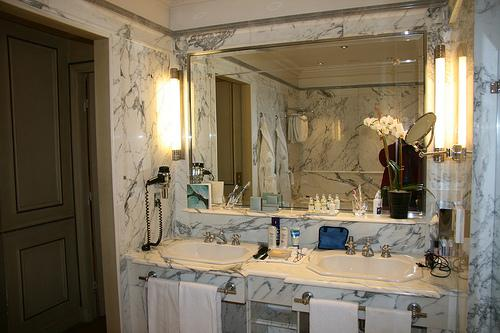What devices are mounted on the wall, and where are they located? There is a mounted light near the large mirror and a hairdryer mounted next to the right sink. Discuss the types of lights visible in the scene and their locations. There are lights on both sides of the large mirror, a light on a mirror to the left, and a light near a mirror on the right. Briefly describe the layout of the presented bathroom. It's a large bathroom with a double sink, marble counter, large mirror, lights on both sides of the mirror, wall-mounted hairdryer, and towels hanging below the counter. What items are placed on the bathroom counter? A blue bag, containers, toothbrushes in glasses, and a black cord can be found on the counter. What plants can you find in the image? There is a tall flower in a black pot placed in front of the mirror. Describe the towels in the image and their location. There are two white towels hanging on a silver towel rack below the bathroom counter. What objects can you find in the bathroom scene? There are a mounted light, hairdryer, mirrors, sinks, faucets, towels, toothbrushes, flower in a pot, and various toiletries. Could you mention the types of toothbrushes present in the scene and their location? There is a blue toothbrush in a glass on the left, and a red toothbrush in a glass on the right. Identify the unique features of the bathroom sink area. The sink area is made of marble, has a double sink, silver sink fixtures, and has clutter on the counter. How many mirrors are there in the image, and can you describe the most prominent one? There are three mirrors, with the most prominent one being a large silver-framed bathroom mirror above the sinks. 